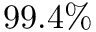<formula> <loc_0><loc_0><loc_500><loc_500>9 9 . 4 \%</formula> 